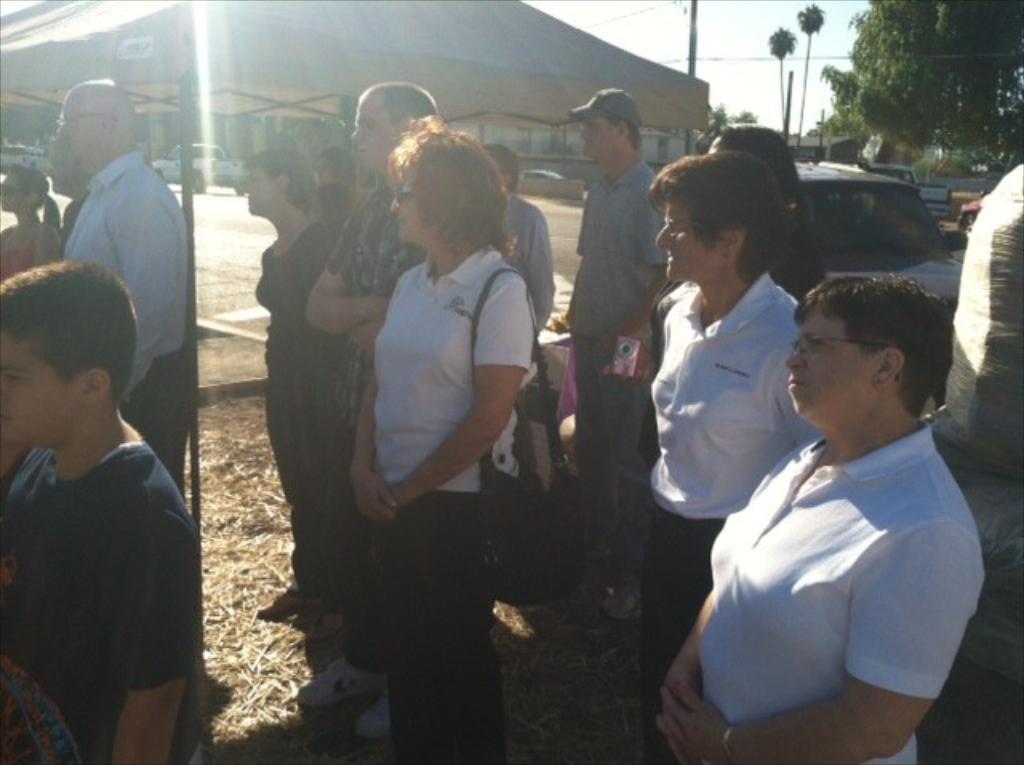Describe this image in one or two sentences. This picture is clicked outside. In the foreground we can see the group of people standing on the ground and we can see the grass, camera, sling bag, a vehicle and some other objects. In the center we can see the vehicles seems to be running on the road and we can see the trees, cable, building like object. In the background we can see the sky, trees and some other objects. 